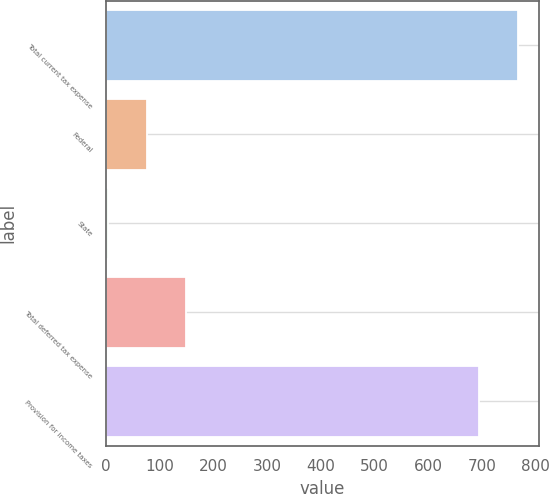<chart> <loc_0><loc_0><loc_500><loc_500><bar_chart><fcel>Total current tax expense<fcel>Federal<fcel>State<fcel>Total deferred tax expense<fcel>Provision for income taxes<nl><fcel>767.9<fcel>75.9<fcel>3<fcel>148.8<fcel>695<nl></chart> 